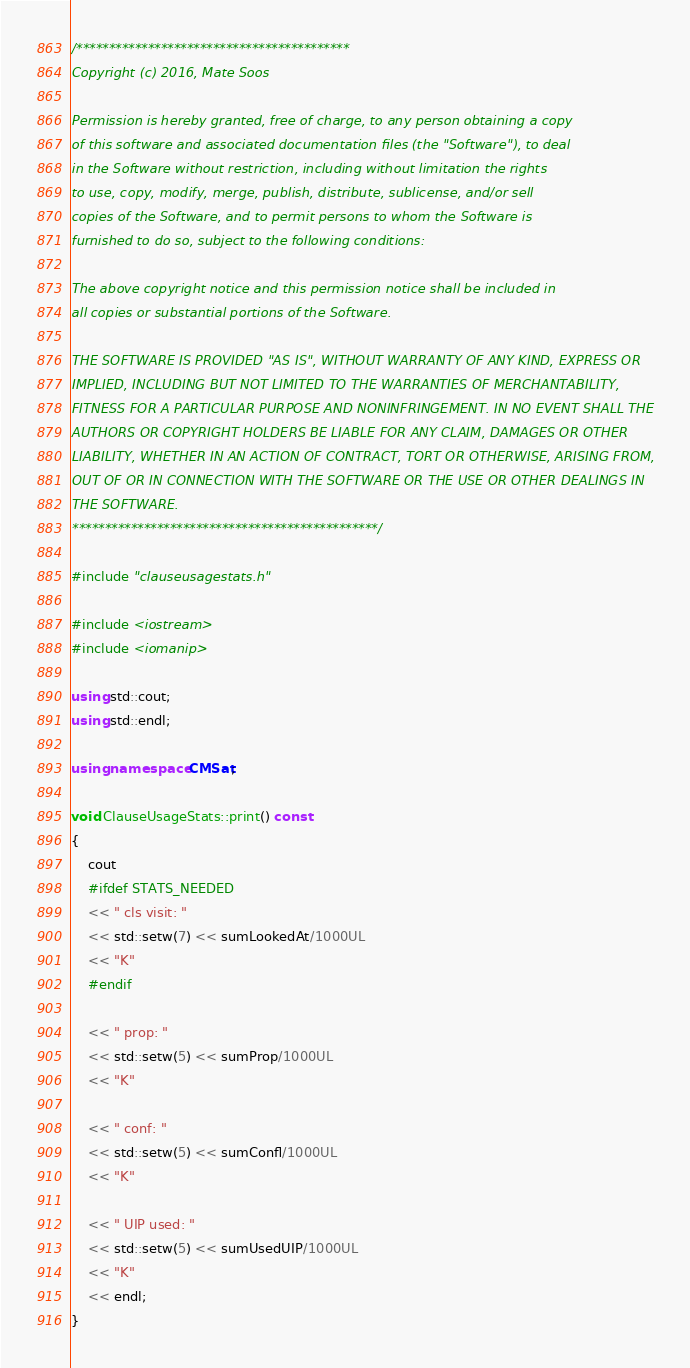Convert code to text. <code><loc_0><loc_0><loc_500><loc_500><_C++_>/******************************************
Copyright (c) 2016, Mate Soos

Permission is hereby granted, free of charge, to any person obtaining a copy
of this software and associated documentation files (the "Software"), to deal
in the Software without restriction, including without limitation the rights
to use, copy, modify, merge, publish, distribute, sublicense, and/or sell
copies of the Software, and to permit persons to whom the Software is
furnished to do so, subject to the following conditions:

The above copyright notice and this permission notice shall be included in
all copies or substantial portions of the Software.

THE SOFTWARE IS PROVIDED "AS IS", WITHOUT WARRANTY OF ANY KIND, EXPRESS OR
IMPLIED, INCLUDING BUT NOT LIMITED TO THE WARRANTIES OF MERCHANTABILITY,
FITNESS FOR A PARTICULAR PURPOSE AND NONINFRINGEMENT. IN NO EVENT SHALL THE
AUTHORS OR COPYRIGHT HOLDERS BE LIABLE FOR ANY CLAIM, DAMAGES OR OTHER
LIABILITY, WHETHER IN AN ACTION OF CONTRACT, TORT OR OTHERWISE, ARISING FROM,
OUT OF OR IN CONNECTION WITH THE SOFTWARE OR THE USE OR OTHER DEALINGS IN
THE SOFTWARE.
***********************************************/

#include "clauseusagestats.h"

#include <iostream>
#include <iomanip>

using std::cout;
using std::endl;

using namespace CMSat;

void ClauseUsageStats::print() const
{
    cout
    #ifdef STATS_NEEDED
    << " cls visit: "
    << std::setw(7) << sumLookedAt/1000UL
    << "K"
    #endif

    << " prop: "
    << std::setw(5) << sumProp/1000UL
    << "K"

    << " conf: "
    << std::setw(5) << sumConfl/1000UL
    << "K"

    << " UIP used: "
    << std::setw(5) << sumUsedUIP/1000UL
    << "K"
    << endl;
}
</code> 